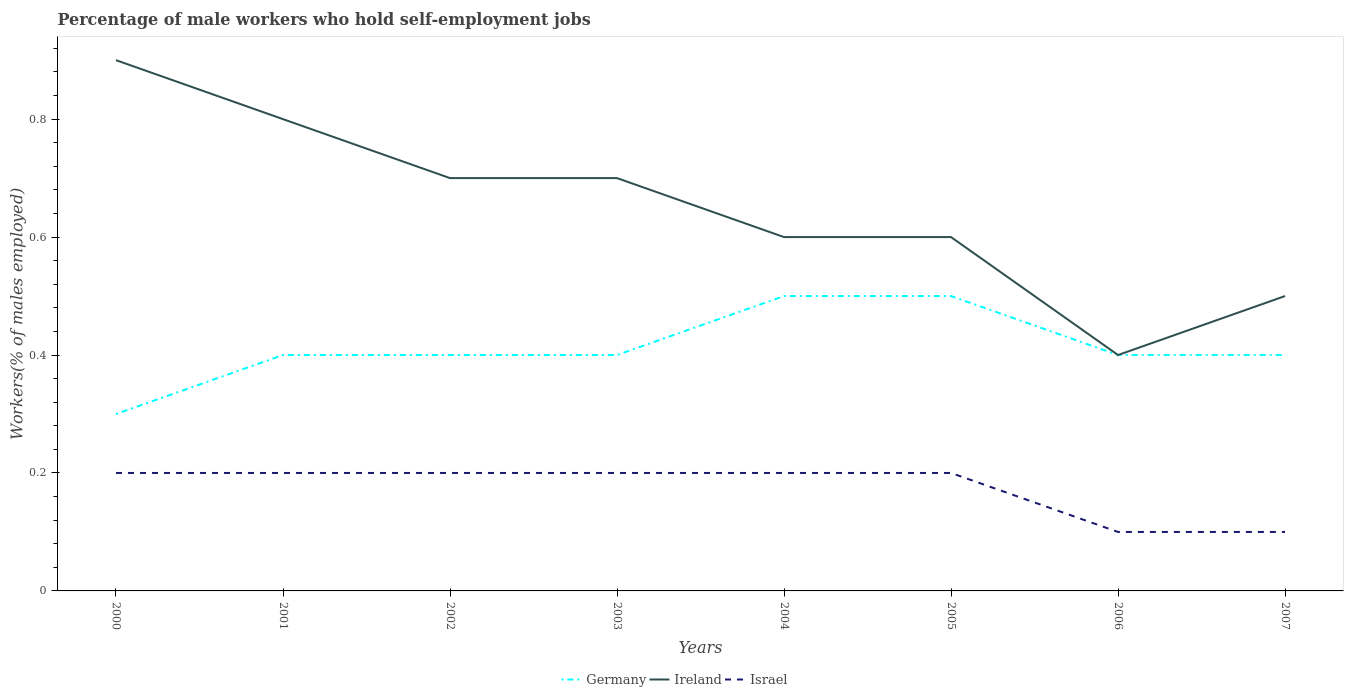How many different coloured lines are there?
Offer a terse response. 3. Is the number of lines equal to the number of legend labels?
Your response must be concise. Yes. Across all years, what is the maximum percentage of self-employed male workers in Israel?
Provide a succinct answer. 0.1. In which year was the percentage of self-employed male workers in Israel maximum?
Offer a very short reply. 2006. What is the total percentage of self-employed male workers in Ireland in the graph?
Your answer should be very brief. 0.3. What is the difference between the highest and the second highest percentage of self-employed male workers in Germany?
Offer a terse response. 0.2. What is the difference between the highest and the lowest percentage of self-employed male workers in Israel?
Provide a short and direct response. 6. How many years are there in the graph?
Offer a very short reply. 8. Does the graph contain any zero values?
Offer a very short reply. No. How many legend labels are there?
Give a very brief answer. 3. What is the title of the graph?
Your response must be concise. Percentage of male workers who hold self-employment jobs. Does "Mauritania" appear as one of the legend labels in the graph?
Provide a short and direct response. No. What is the label or title of the Y-axis?
Offer a very short reply. Workers(% of males employed). What is the Workers(% of males employed) of Germany in 2000?
Make the answer very short. 0.3. What is the Workers(% of males employed) of Ireland in 2000?
Your response must be concise. 0.9. What is the Workers(% of males employed) of Israel in 2000?
Ensure brevity in your answer.  0.2. What is the Workers(% of males employed) of Germany in 2001?
Make the answer very short. 0.4. What is the Workers(% of males employed) of Ireland in 2001?
Offer a very short reply. 0.8. What is the Workers(% of males employed) in Israel in 2001?
Your response must be concise. 0.2. What is the Workers(% of males employed) in Germany in 2002?
Make the answer very short. 0.4. What is the Workers(% of males employed) in Ireland in 2002?
Provide a succinct answer. 0.7. What is the Workers(% of males employed) of Israel in 2002?
Your answer should be very brief. 0.2. What is the Workers(% of males employed) of Germany in 2003?
Offer a terse response. 0.4. What is the Workers(% of males employed) in Ireland in 2003?
Your answer should be compact. 0.7. What is the Workers(% of males employed) of Israel in 2003?
Your answer should be compact. 0.2. What is the Workers(% of males employed) of Germany in 2004?
Your answer should be compact. 0.5. What is the Workers(% of males employed) in Ireland in 2004?
Make the answer very short. 0.6. What is the Workers(% of males employed) of Israel in 2004?
Provide a succinct answer. 0.2. What is the Workers(% of males employed) of Ireland in 2005?
Offer a very short reply. 0.6. What is the Workers(% of males employed) of Israel in 2005?
Offer a terse response. 0.2. What is the Workers(% of males employed) in Germany in 2006?
Offer a very short reply. 0.4. What is the Workers(% of males employed) of Ireland in 2006?
Your answer should be very brief. 0.4. What is the Workers(% of males employed) in Israel in 2006?
Make the answer very short. 0.1. What is the Workers(% of males employed) in Germany in 2007?
Make the answer very short. 0.4. What is the Workers(% of males employed) in Ireland in 2007?
Your response must be concise. 0.5. What is the Workers(% of males employed) in Israel in 2007?
Make the answer very short. 0.1. Across all years, what is the maximum Workers(% of males employed) of Ireland?
Offer a terse response. 0.9. Across all years, what is the maximum Workers(% of males employed) of Israel?
Make the answer very short. 0.2. Across all years, what is the minimum Workers(% of males employed) in Germany?
Keep it short and to the point. 0.3. Across all years, what is the minimum Workers(% of males employed) of Ireland?
Keep it short and to the point. 0.4. Across all years, what is the minimum Workers(% of males employed) in Israel?
Offer a very short reply. 0.1. What is the total Workers(% of males employed) of Ireland in the graph?
Offer a terse response. 5.2. What is the difference between the Workers(% of males employed) of Ireland in 2000 and that in 2001?
Ensure brevity in your answer.  0.1. What is the difference between the Workers(% of males employed) of Israel in 2000 and that in 2001?
Keep it short and to the point. 0. What is the difference between the Workers(% of males employed) of Ireland in 2000 and that in 2002?
Ensure brevity in your answer.  0.2. What is the difference between the Workers(% of males employed) in Germany in 2000 and that in 2003?
Make the answer very short. -0.1. What is the difference between the Workers(% of males employed) of Ireland in 2000 and that in 2004?
Your response must be concise. 0.3. What is the difference between the Workers(% of males employed) in Germany in 2000 and that in 2005?
Provide a succinct answer. -0.2. What is the difference between the Workers(% of males employed) in Ireland in 2000 and that in 2005?
Make the answer very short. 0.3. What is the difference between the Workers(% of males employed) of Israel in 2000 and that in 2005?
Give a very brief answer. 0. What is the difference between the Workers(% of males employed) in Ireland in 2000 and that in 2006?
Make the answer very short. 0.5. What is the difference between the Workers(% of males employed) in Israel in 2000 and that in 2006?
Make the answer very short. 0.1. What is the difference between the Workers(% of males employed) of Ireland in 2000 and that in 2007?
Your answer should be compact. 0.4. What is the difference between the Workers(% of males employed) in Ireland in 2001 and that in 2002?
Keep it short and to the point. 0.1. What is the difference between the Workers(% of males employed) in Israel in 2001 and that in 2002?
Make the answer very short. 0. What is the difference between the Workers(% of males employed) in Germany in 2001 and that in 2003?
Your answer should be very brief. 0. What is the difference between the Workers(% of males employed) in Ireland in 2001 and that in 2003?
Your answer should be very brief. 0.1. What is the difference between the Workers(% of males employed) of Israel in 2001 and that in 2004?
Give a very brief answer. 0. What is the difference between the Workers(% of males employed) of Ireland in 2001 and that in 2005?
Make the answer very short. 0.2. What is the difference between the Workers(% of males employed) of Israel in 2001 and that in 2005?
Your answer should be very brief. 0. What is the difference between the Workers(% of males employed) in Ireland in 2001 and that in 2006?
Offer a very short reply. 0.4. What is the difference between the Workers(% of males employed) in Israel in 2001 and that in 2007?
Your response must be concise. 0.1. What is the difference between the Workers(% of males employed) of Ireland in 2002 and that in 2003?
Give a very brief answer. 0. What is the difference between the Workers(% of males employed) of Israel in 2002 and that in 2003?
Provide a short and direct response. 0. What is the difference between the Workers(% of males employed) of Ireland in 2002 and that in 2004?
Provide a succinct answer. 0.1. What is the difference between the Workers(% of males employed) in Germany in 2002 and that in 2005?
Your answer should be very brief. -0.1. What is the difference between the Workers(% of males employed) in Ireland in 2002 and that in 2005?
Keep it short and to the point. 0.1. What is the difference between the Workers(% of males employed) of Germany in 2002 and that in 2006?
Your response must be concise. 0. What is the difference between the Workers(% of males employed) of Israel in 2002 and that in 2006?
Your answer should be very brief. 0.1. What is the difference between the Workers(% of males employed) of Ireland in 2002 and that in 2007?
Your response must be concise. 0.2. What is the difference between the Workers(% of males employed) of Ireland in 2003 and that in 2004?
Your response must be concise. 0.1. What is the difference between the Workers(% of males employed) in Israel in 2003 and that in 2004?
Your answer should be compact. 0. What is the difference between the Workers(% of males employed) of Germany in 2003 and that in 2005?
Your answer should be compact. -0.1. What is the difference between the Workers(% of males employed) in Ireland in 2003 and that in 2005?
Ensure brevity in your answer.  0.1. What is the difference between the Workers(% of males employed) of Ireland in 2003 and that in 2006?
Offer a very short reply. 0.3. What is the difference between the Workers(% of males employed) of Israel in 2003 and that in 2006?
Keep it short and to the point. 0.1. What is the difference between the Workers(% of males employed) in Germany in 2003 and that in 2007?
Your answer should be very brief. 0. What is the difference between the Workers(% of males employed) of Israel in 2004 and that in 2007?
Your answer should be compact. 0.1. What is the difference between the Workers(% of males employed) in Israel in 2005 and that in 2006?
Your answer should be very brief. 0.1. What is the difference between the Workers(% of males employed) in Germany in 2005 and that in 2007?
Give a very brief answer. 0.1. What is the difference between the Workers(% of males employed) in Germany in 2006 and that in 2007?
Provide a succinct answer. 0. What is the difference between the Workers(% of males employed) in Ireland in 2006 and that in 2007?
Offer a terse response. -0.1. What is the difference between the Workers(% of males employed) of Germany in 2000 and the Workers(% of males employed) of Ireland in 2001?
Your answer should be very brief. -0.5. What is the difference between the Workers(% of males employed) in Germany in 2000 and the Workers(% of males employed) in Israel in 2001?
Your response must be concise. 0.1. What is the difference between the Workers(% of males employed) in Germany in 2000 and the Workers(% of males employed) in Ireland in 2002?
Provide a succinct answer. -0.4. What is the difference between the Workers(% of males employed) of Ireland in 2000 and the Workers(% of males employed) of Israel in 2002?
Keep it short and to the point. 0.7. What is the difference between the Workers(% of males employed) in Germany in 2000 and the Workers(% of males employed) in Ireland in 2003?
Offer a terse response. -0.4. What is the difference between the Workers(% of males employed) in Germany in 2000 and the Workers(% of males employed) in Israel in 2003?
Your answer should be very brief. 0.1. What is the difference between the Workers(% of males employed) of Ireland in 2000 and the Workers(% of males employed) of Israel in 2004?
Make the answer very short. 0.7. What is the difference between the Workers(% of males employed) in Germany in 2000 and the Workers(% of males employed) in Ireland in 2007?
Ensure brevity in your answer.  -0.2. What is the difference between the Workers(% of males employed) of Germany in 2000 and the Workers(% of males employed) of Israel in 2007?
Your answer should be very brief. 0.2. What is the difference between the Workers(% of males employed) of Ireland in 2000 and the Workers(% of males employed) of Israel in 2007?
Ensure brevity in your answer.  0.8. What is the difference between the Workers(% of males employed) in Ireland in 2001 and the Workers(% of males employed) in Israel in 2004?
Keep it short and to the point. 0.6. What is the difference between the Workers(% of males employed) of Germany in 2001 and the Workers(% of males employed) of Ireland in 2005?
Make the answer very short. -0.2. What is the difference between the Workers(% of males employed) of Germany in 2001 and the Workers(% of males employed) of Israel in 2005?
Keep it short and to the point. 0.2. What is the difference between the Workers(% of males employed) of Germany in 2001 and the Workers(% of males employed) of Israel in 2006?
Your answer should be compact. 0.3. What is the difference between the Workers(% of males employed) of Germany in 2001 and the Workers(% of males employed) of Ireland in 2007?
Offer a very short reply. -0.1. What is the difference between the Workers(% of males employed) in Germany in 2001 and the Workers(% of males employed) in Israel in 2007?
Ensure brevity in your answer.  0.3. What is the difference between the Workers(% of males employed) of Ireland in 2001 and the Workers(% of males employed) of Israel in 2007?
Offer a terse response. 0.7. What is the difference between the Workers(% of males employed) of Ireland in 2002 and the Workers(% of males employed) of Israel in 2003?
Give a very brief answer. 0.5. What is the difference between the Workers(% of males employed) of Germany in 2002 and the Workers(% of males employed) of Ireland in 2004?
Provide a short and direct response. -0.2. What is the difference between the Workers(% of males employed) in Germany in 2002 and the Workers(% of males employed) in Israel in 2004?
Give a very brief answer. 0.2. What is the difference between the Workers(% of males employed) of Ireland in 2002 and the Workers(% of males employed) of Israel in 2004?
Offer a terse response. 0.5. What is the difference between the Workers(% of males employed) in Germany in 2002 and the Workers(% of males employed) in Ireland in 2005?
Your answer should be very brief. -0.2. What is the difference between the Workers(% of males employed) in Germany in 2002 and the Workers(% of males employed) in Israel in 2005?
Provide a succinct answer. 0.2. What is the difference between the Workers(% of males employed) of Ireland in 2002 and the Workers(% of males employed) of Israel in 2005?
Keep it short and to the point. 0.5. What is the difference between the Workers(% of males employed) of Germany in 2002 and the Workers(% of males employed) of Israel in 2006?
Offer a terse response. 0.3. What is the difference between the Workers(% of males employed) of Germany in 2002 and the Workers(% of males employed) of Ireland in 2007?
Your answer should be compact. -0.1. What is the difference between the Workers(% of males employed) of Germany in 2002 and the Workers(% of males employed) of Israel in 2007?
Make the answer very short. 0.3. What is the difference between the Workers(% of males employed) of Ireland in 2002 and the Workers(% of males employed) of Israel in 2007?
Keep it short and to the point. 0.6. What is the difference between the Workers(% of males employed) in Germany in 2003 and the Workers(% of males employed) in Israel in 2004?
Provide a succinct answer. 0.2. What is the difference between the Workers(% of males employed) of Germany in 2003 and the Workers(% of males employed) of Ireland in 2005?
Provide a succinct answer. -0.2. What is the difference between the Workers(% of males employed) of Germany in 2003 and the Workers(% of males employed) of Israel in 2005?
Give a very brief answer. 0.2. What is the difference between the Workers(% of males employed) of Germany in 2003 and the Workers(% of males employed) of Ireland in 2006?
Your answer should be compact. 0. What is the difference between the Workers(% of males employed) in Ireland in 2003 and the Workers(% of males employed) in Israel in 2007?
Your answer should be compact. 0.6. What is the difference between the Workers(% of males employed) in Germany in 2004 and the Workers(% of males employed) in Ireland in 2005?
Your answer should be very brief. -0.1. What is the difference between the Workers(% of males employed) of Ireland in 2004 and the Workers(% of males employed) of Israel in 2005?
Ensure brevity in your answer.  0.4. What is the difference between the Workers(% of males employed) in Germany in 2004 and the Workers(% of males employed) in Israel in 2007?
Give a very brief answer. 0.4. What is the difference between the Workers(% of males employed) in Ireland in 2005 and the Workers(% of males employed) in Israel in 2006?
Your answer should be very brief. 0.5. What is the difference between the Workers(% of males employed) in Germany in 2005 and the Workers(% of males employed) in Ireland in 2007?
Your answer should be very brief. 0. What is the difference between the Workers(% of males employed) in Germany in 2005 and the Workers(% of males employed) in Israel in 2007?
Ensure brevity in your answer.  0.4. What is the difference between the Workers(% of males employed) of Ireland in 2005 and the Workers(% of males employed) of Israel in 2007?
Offer a very short reply. 0.5. What is the difference between the Workers(% of males employed) in Germany in 2006 and the Workers(% of males employed) in Ireland in 2007?
Provide a short and direct response. -0.1. What is the average Workers(% of males employed) in Germany per year?
Make the answer very short. 0.41. What is the average Workers(% of males employed) in Ireland per year?
Your response must be concise. 0.65. What is the average Workers(% of males employed) in Israel per year?
Offer a very short reply. 0.17. In the year 2000, what is the difference between the Workers(% of males employed) of Germany and Workers(% of males employed) of Ireland?
Your answer should be compact. -0.6. In the year 2000, what is the difference between the Workers(% of males employed) of Germany and Workers(% of males employed) of Israel?
Ensure brevity in your answer.  0.1. In the year 2001, what is the difference between the Workers(% of males employed) in Ireland and Workers(% of males employed) in Israel?
Provide a short and direct response. 0.6. In the year 2002, what is the difference between the Workers(% of males employed) in Ireland and Workers(% of males employed) in Israel?
Your response must be concise. 0.5. In the year 2003, what is the difference between the Workers(% of males employed) in Germany and Workers(% of males employed) in Ireland?
Your answer should be compact. -0.3. In the year 2003, what is the difference between the Workers(% of males employed) of Ireland and Workers(% of males employed) of Israel?
Your response must be concise. 0.5. In the year 2004, what is the difference between the Workers(% of males employed) of Germany and Workers(% of males employed) of Israel?
Give a very brief answer. 0.3. In the year 2006, what is the difference between the Workers(% of males employed) in Germany and Workers(% of males employed) in Ireland?
Offer a terse response. 0. In the year 2006, what is the difference between the Workers(% of males employed) in Germany and Workers(% of males employed) in Israel?
Keep it short and to the point. 0.3. In the year 2006, what is the difference between the Workers(% of males employed) of Ireland and Workers(% of males employed) of Israel?
Offer a very short reply. 0.3. In the year 2007, what is the difference between the Workers(% of males employed) in Germany and Workers(% of males employed) in Ireland?
Provide a succinct answer. -0.1. In the year 2007, what is the difference between the Workers(% of males employed) in Germany and Workers(% of males employed) in Israel?
Your answer should be very brief. 0.3. In the year 2007, what is the difference between the Workers(% of males employed) in Ireland and Workers(% of males employed) in Israel?
Offer a terse response. 0.4. What is the ratio of the Workers(% of males employed) of Germany in 2000 to that in 2001?
Provide a short and direct response. 0.75. What is the ratio of the Workers(% of males employed) of Germany in 2000 to that in 2002?
Give a very brief answer. 0.75. What is the ratio of the Workers(% of males employed) of Ireland in 2000 to that in 2002?
Your answer should be compact. 1.29. What is the ratio of the Workers(% of males employed) in Israel in 2000 to that in 2002?
Ensure brevity in your answer.  1. What is the ratio of the Workers(% of males employed) in Ireland in 2000 to that in 2003?
Keep it short and to the point. 1.29. What is the ratio of the Workers(% of males employed) of Ireland in 2000 to that in 2005?
Ensure brevity in your answer.  1.5. What is the ratio of the Workers(% of males employed) of Germany in 2000 to that in 2006?
Your response must be concise. 0.75. What is the ratio of the Workers(% of males employed) of Ireland in 2000 to that in 2006?
Make the answer very short. 2.25. What is the ratio of the Workers(% of males employed) of Germany in 2001 to that in 2002?
Give a very brief answer. 1. What is the ratio of the Workers(% of males employed) of Ireland in 2001 to that in 2002?
Your answer should be very brief. 1.14. What is the ratio of the Workers(% of males employed) of Israel in 2001 to that in 2002?
Provide a succinct answer. 1. What is the ratio of the Workers(% of males employed) in Ireland in 2001 to that in 2003?
Provide a succinct answer. 1.14. What is the ratio of the Workers(% of males employed) of Ireland in 2001 to that in 2004?
Give a very brief answer. 1.33. What is the ratio of the Workers(% of males employed) of Israel in 2001 to that in 2004?
Your answer should be very brief. 1. What is the ratio of the Workers(% of males employed) in Israel in 2001 to that in 2005?
Your response must be concise. 1. What is the ratio of the Workers(% of males employed) of Germany in 2001 to that in 2006?
Ensure brevity in your answer.  1. What is the ratio of the Workers(% of males employed) of Ireland in 2001 to that in 2006?
Make the answer very short. 2. What is the ratio of the Workers(% of males employed) of Israel in 2001 to that in 2006?
Your answer should be very brief. 2. What is the ratio of the Workers(% of males employed) in Israel in 2001 to that in 2007?
Provide a short and direct response. 2. What is the ratio of the Workers(% of males employed) in Germany in 2002 to that in 2003?
Offer a terse response. 1. What is the ratio of the Workers(% of males employed) of Ireland in 2002 to that in 2003?
Offer a very short reply. 1. What is the ratio of the Workers(% of males employed) in Germany in 2002 to that in 2004?
Ensure brevity in your answer.  0.8. What is the ratio of the Workers(% of males employed) in Ireland in 2002 to that in 2004?
Make the answer very short. 1.17. What is the ratio of the Workers(% of males employed) in Germany in 2002 to that in 2005?
Offer a terse response. 0.8. What is the ratio of the Workers(% of males employed) in Germany in 2002 to that in 2006?
Offer a very short reply. 1. What is the ratio of the Workers(% of males employed) in Germany in 2002 to that in 2007?
Make the answer very short. 1. What is the ratio of the Workers(% of males employed) of Israel in 2002 to that in 2007?
Offer a very short reply. 2. What is the ratio of the Workers(% of males employed) in Ireland in 2003 to that in 2004?
Offer a very short reply. 1.17. What is the ratio of the Workers(% of males employed) of Israel in 2003 to that in 2004?
Your answer should be compact. 1. What is the ratio of the Workers(% of males employed) of Ireland in 2003 to that in 2005?
Keep it short and to the point. 1.17. What is the ratio of the Workers(% of males employed) of Israel in 2003 to that in 2005?
Your answer should be compact. 1. What is the ratio of the Workers(% of males employed) of Germany in 2003 to that in 2007?
Make the answer very short. 1. What is the ratio of the Workers(% of males employed) of Israel in 2003 to that in 2007?
Your response must be concise. 2. What is the ratio of the Workers(% of males employed) in Germany in 2004 to that in 2005?
Offer a very short reply. 1. What is the ratio of the Workers(% of males employed) of Ireland in 2004 to that in 2005?
Make the answer very short. 1. What is the ratio of the Workers(% of males employed) in Israel in 2004 to that in 2005?
Make the answer very short. 1. What is the ratio of the Workers(% of males employed) in Ireland in 2004 to that in 2006?
Your answer should be compact. 1.5. What is the ratio of the Workers(% of males employed) of Germany in 2004 to that in 2007?
Provide a succinct answer. 1.25. What is the ratio of the Workers(% of males employed) in Ireland in 2004 to that in 2007?
Provide a succinct answer. 1.2. What is the ratio of the Workers(% of males employed) in Ireland in 2005 to that in 2006?
Offer a terse response. 1.5. What is the ratio of the Workers(% of males employed) of Israel in 2005 to that in 2006?
Offer a very short reply. 2. What is the ratio of the Workers(% of males employed) of Ireland in 2005 to that in 2007?
Make the answer very short. 1.2. What is the ratio of the Workers(% of males employed) of Germany in 2006 to that in 2007?
Ensure brevity in your answer.  1. What is the ratio of the Workers(% of males employed) in Israel in 2006 to that in 2007?
Ensure brevity in your answer.  1. What is the difference between the highest and the second highest Workers(% of males employed) of Germany?
Your answer should be very brief. 0. What is the difference between the highest and the second highest Workers(% of males employed) of Ireland?
Give a very brief answer. 0.1. What is the difference between the highest and the second highest Workers(% of males employed) in Israel?
Keep it short and to the point. 0. What is the difference between the highest and the lowest Workers(% of males employed) in Germany?
Ensure brevity in your answer.  0.2. 